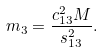<formula> <loc_0><loc_0><loc_500><loc_500>m _ { 3 } = \frac { c ^ { 2 } _ { 1 3 } M } { s _ { 1 3 } ^ { 2 } } .</formula> 